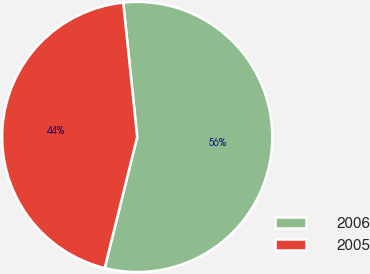Convert chart. <chart><loc_0><loc_0><loc_500><loc_500><pie_chart><fcel>2006<fcel>2005<nl><fcel>55.52%<fcel>44.48%<nl></chart> 